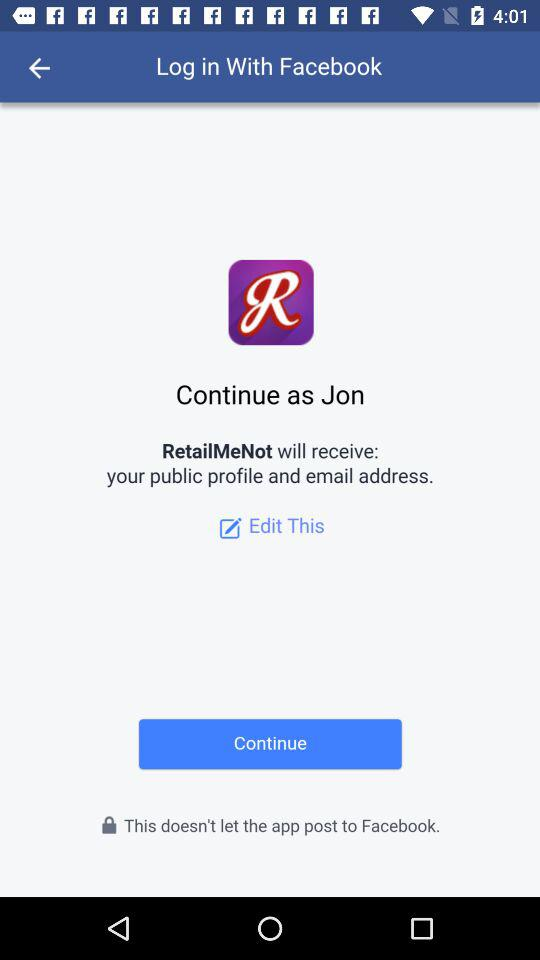What application is asking for permission? The application asking for permission is "RetailMeNot". 